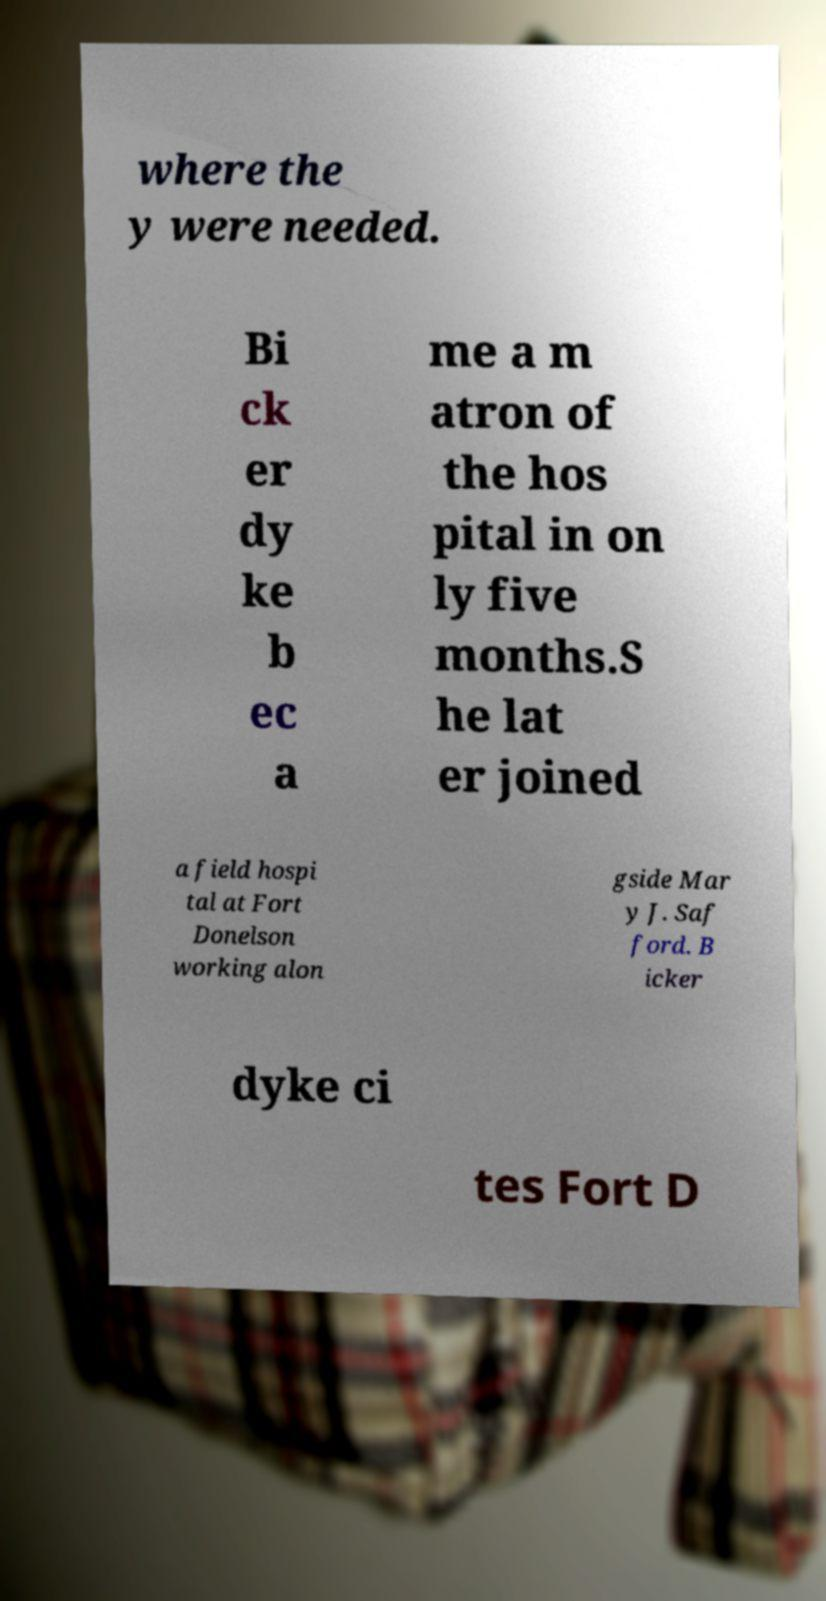Can you read and provide the text displayed in the image?This photo seems to have some interesting text. Can you extract and type it out for me? where the y were needed. Bi ck er dy ke b ec a me a m atron of the hos pital in on ly five months.S he lat er joined a field hospi tal at Fort Donelson working alon gside Mar y J. Saf ford. B icker dyke ci tes Fort D 